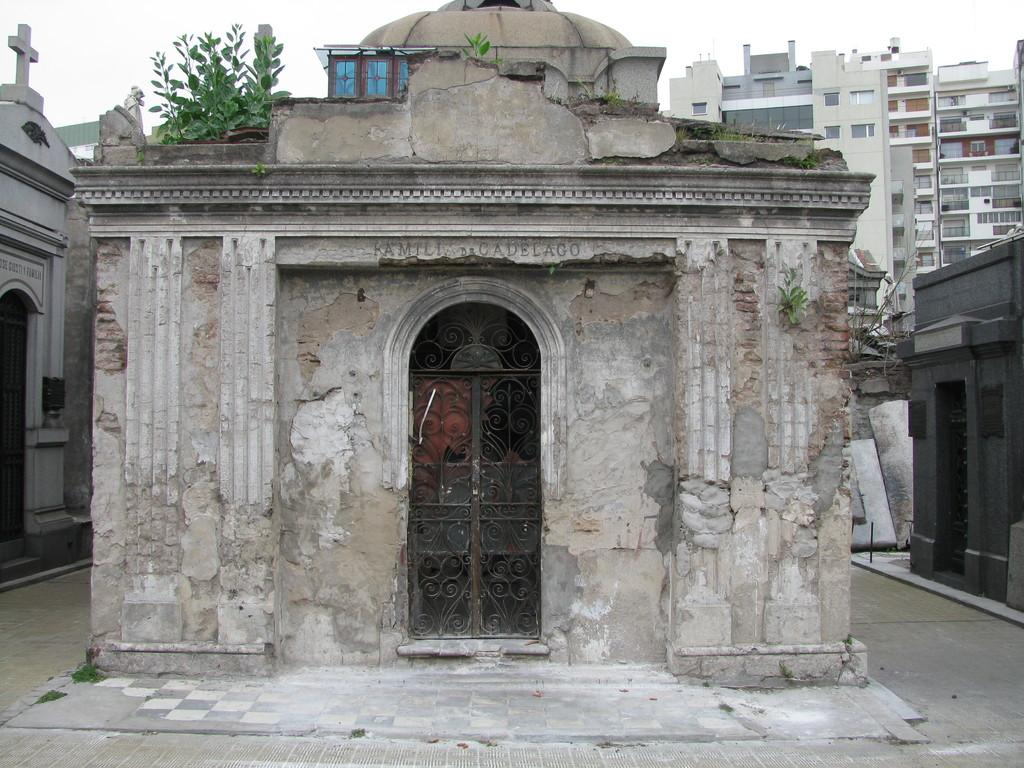What type of structures can be seen in the image? There are buildings in the image. What else can be seen besides the buildings? There are plants and objects in the image. What can be seen in the background of the image? The sky is visible in the background of the image. What invention is being demonstrated by the roll in the image? There is no roll or invention present in the image. How many planes can be seen flying in the image? There are no planes visible in the image. 